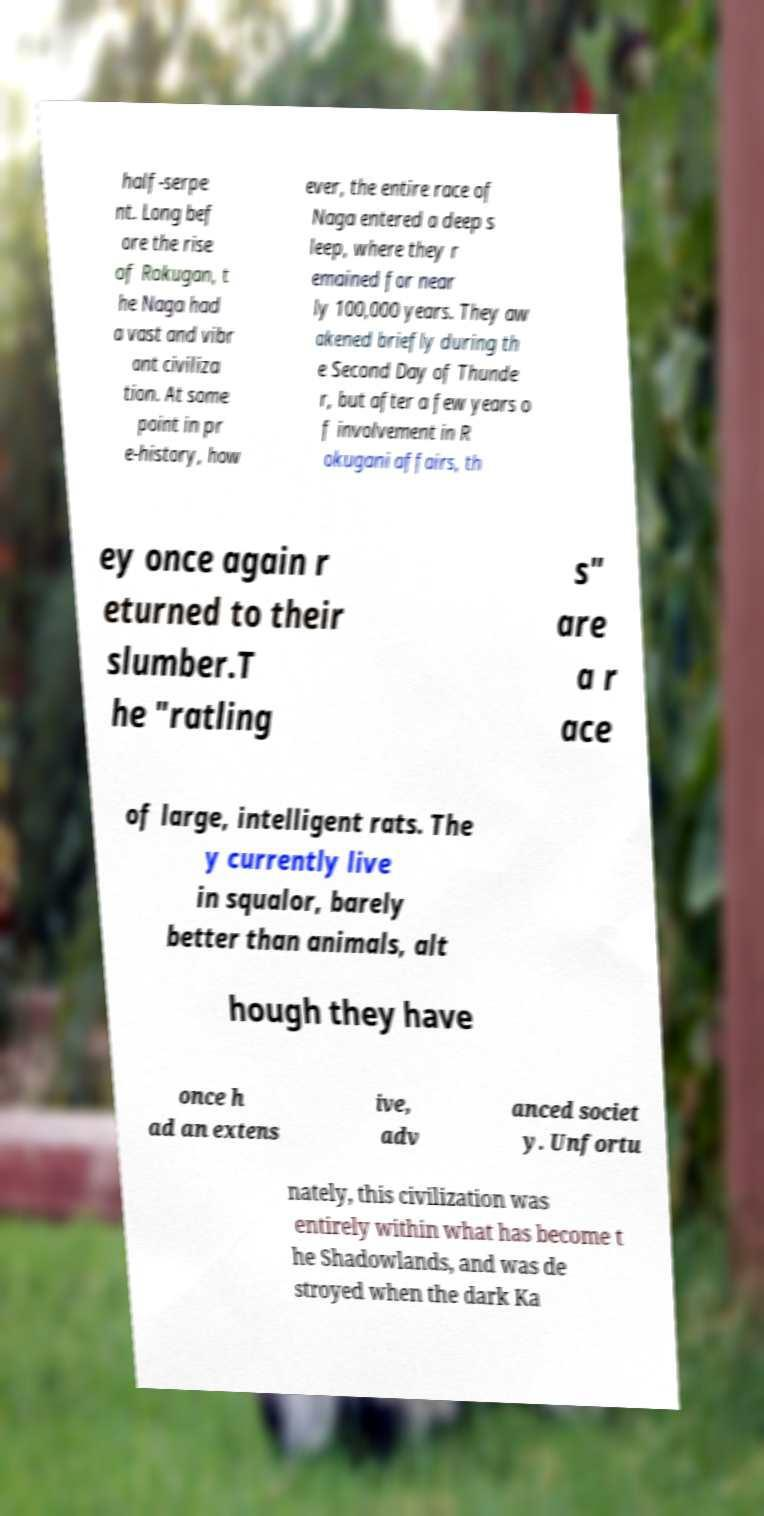There's text embedded in this image that I need extracted. Can you transcribe it verbatim? half-serpe nt. Long bef ore the rise of Rokugan, t he Naga had a vast and vibr ant civiliza tion. At some point in pr e-history, how ever, the entire race of Naga entered a deep s leep, where they r emained for near ly 100,000 years. They aw akened briefly during th e Second Day of Thunde r, but after a few years o f involvement in R okugani affairs, th ey once again r eturned to their slumber.T he "ratling s" are a r ace of large, intelligent rats. The y currently live in squalor, barely better than animals, alt hough they have once h ad an extens ive, adv anced societ y. Unfortu nately, this civilization was entirely within what has become t he Shadowlands, and was de stroyed when the dark Ka 